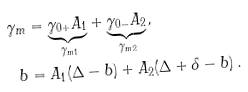<formula> <loc_0><loc_0><loc_500><loc_500>\gamma _ { m } & = \underbrace { \gamma _ { 0 + } A _ { 1 } } _ { \gamma _ { m 1 } } + \underbrace { \gamma _ { 0 - } A _ { 2 } } _ { \gamma _ { m 2 } } , \\ b & = A _ { 1 } ( \Delta - b ) + A _ { 2 } ( \Delta + \delta - b ) \, .</formula> 